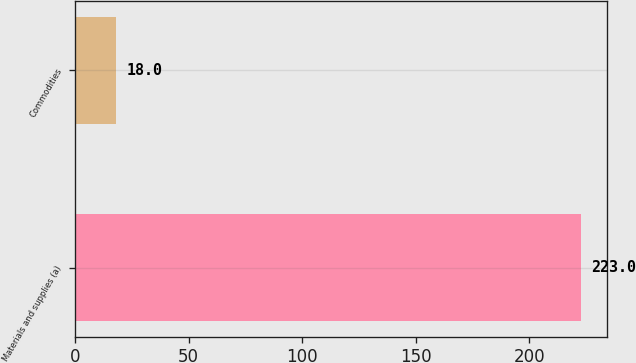Convert chart to OTSL. <chart><loc_0><loc_0><loc_500><loc_500><bar_chart><fcel>Materials and supplies (a)<fcel>Commodities<nl><fcel>223<fcel>18<nl></chart> 